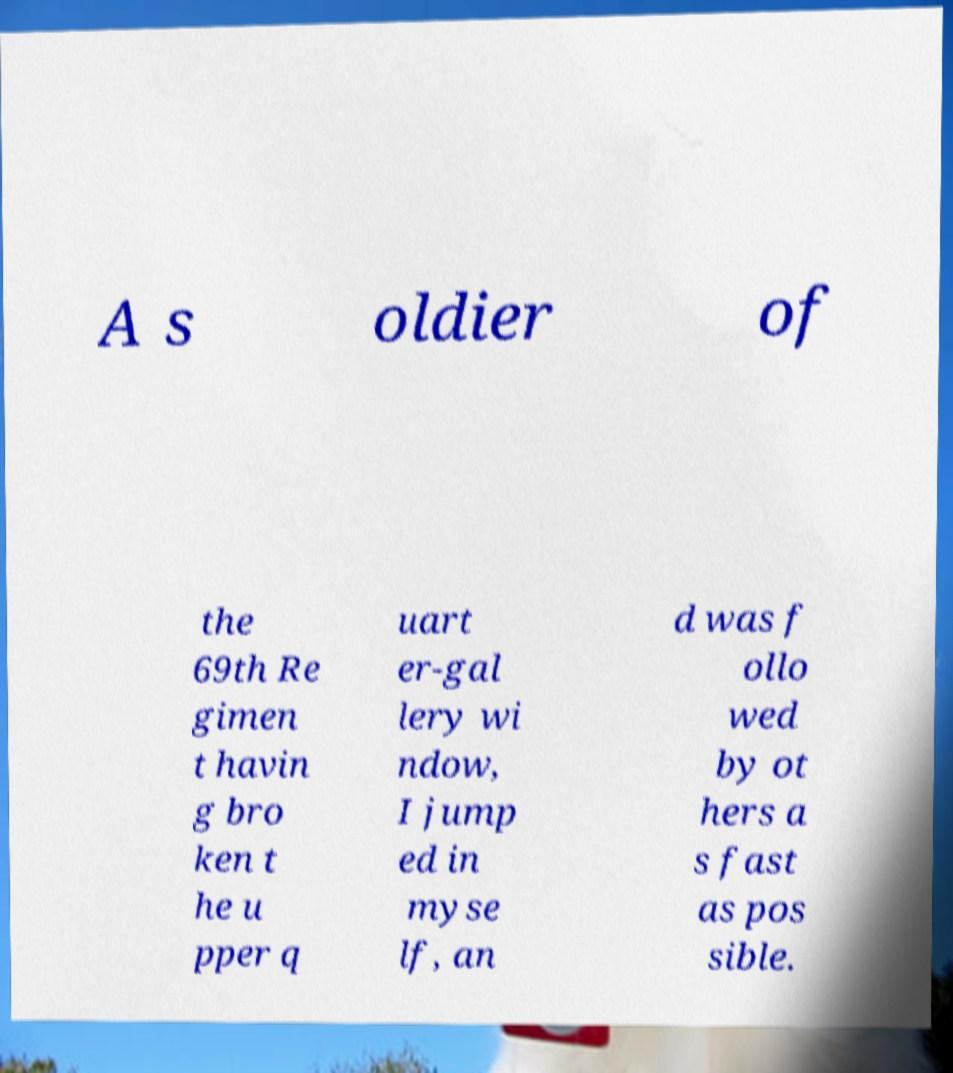What messages or text are displayed in this image? I need them in a readable, typed format. A s oldier of the 69th Re gimen t havin g bro ken t he u pper q uart er-gal lery wi ndow, I jump ed in myse lf, an d was f ollo wed by ot hers a s fast as pos sible. 